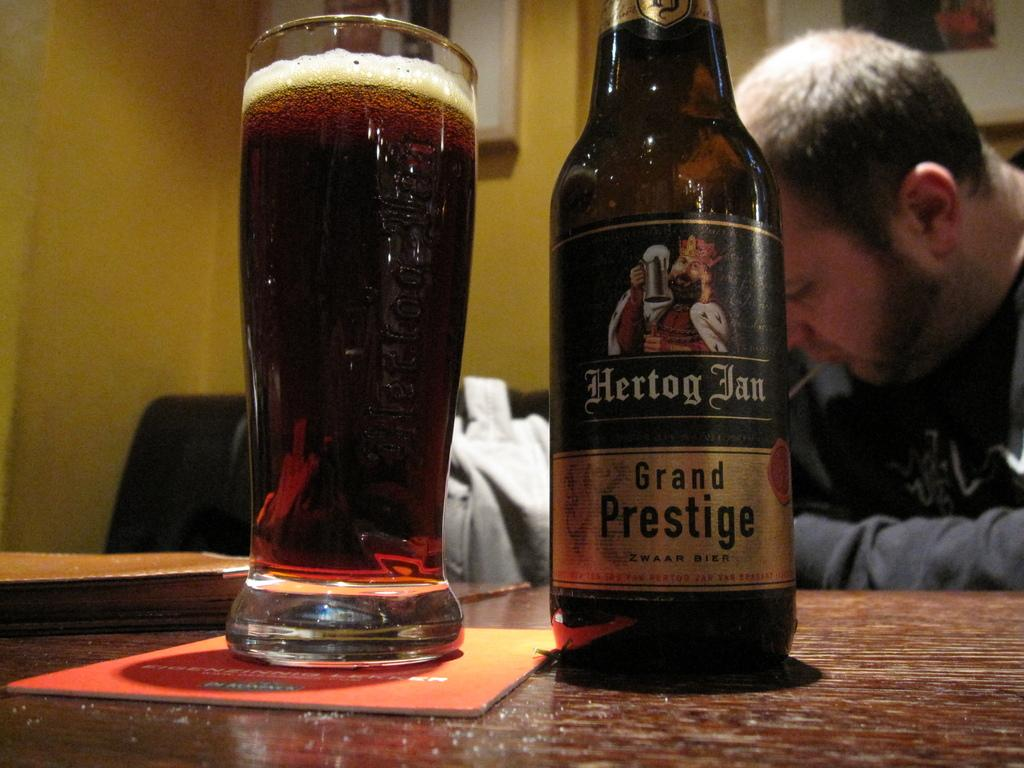What is on the table in the image? There is a glass and a bottle on the table in the image. What else can be seen in the image besides the table? There is a book, a man, a yellow-colored wall in the background, and frames in the background. What is the man in the image doing? The facts provided do not specify what the man is doing. What color is the wall in the background? The wall in the background is yellow-colored. Are there any plantations visible in the image? There is no mention of a plantation in the provided facts, and therefore no such feature can be observed in the image. Can you see any ghosts in the image? There is no mention of a ghost in the provided facts, and therefore no such entity can be observed in the image. 